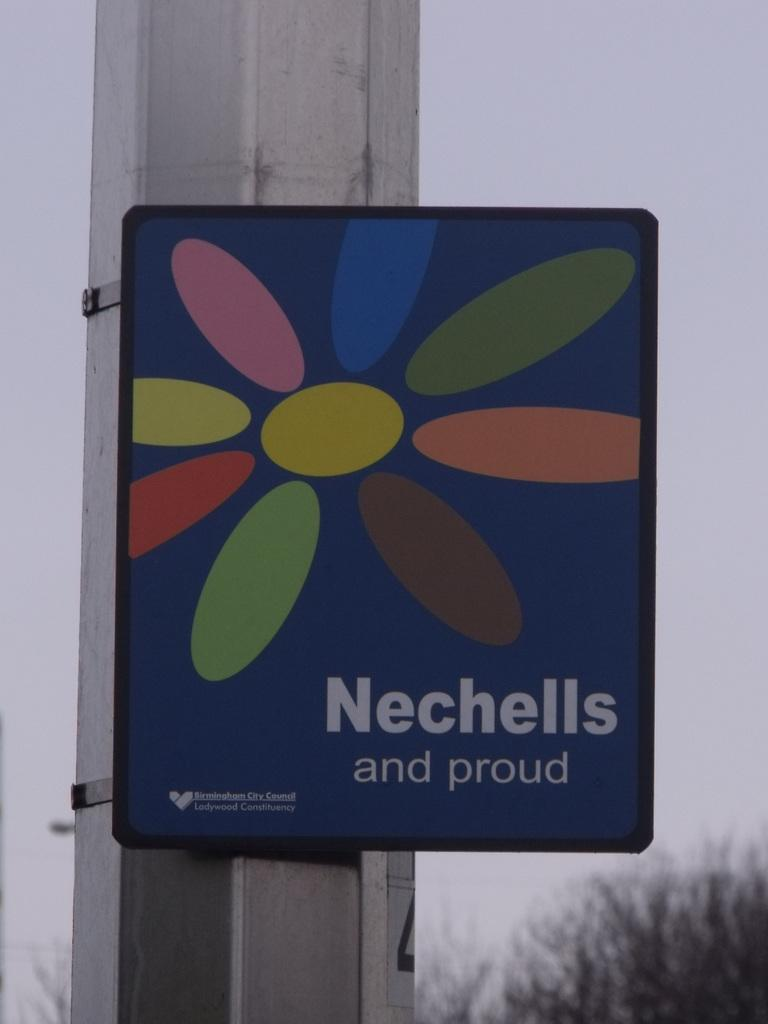<image>
Write a terse but informative summary of the picture. A sign with a flower with various colored petals reading Nechells and proud. 